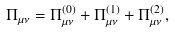Convert formula to latex. <formula><loc_0><loc_0><loc_500><loc_500>\Pi _ { \mu \nu } = \Pi ^ { ( 0 ) } _ { \mu \nu } + \Pi ^ { ( 1 ) } _ { \mu \nu } + \Pi ^ { ( 2 ) } _ { \mu \nu } ,</formula> 